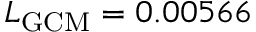Convert formula to latex. <formula><loc_0><loc_0><loc_500><loc_500>L _ { G C M } = 0 . 0 0 5 6 6</formula> 